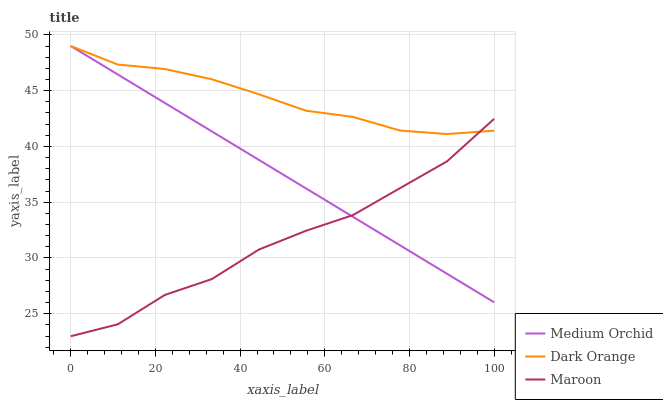Does Maroon have the minimum area under the curve?
Answer yes or no. Yes. Does Dark Orange have the maximum area under the curve?
Answer yes or no. Yes. Does Medium Orchid have the minimum area under the curve?
Answer yes or no. No. Does Medium Orchid have the maximum area under the curve?
Answer yes or no. No. Is Medium Orchid the smoothest?
Answer yes or no. Yes. Is Maroon the roughest?
Answer yes or no. Yes. Is Maroon the smoothest?
Answer yes or no. No. Is Medium Orchid the roughest?
Answer yes or no. No. Does Medium Orchid have the lowest value?
Answer yes or no. No. Does Maroon have the highest value?
Answer yes or no. No. 